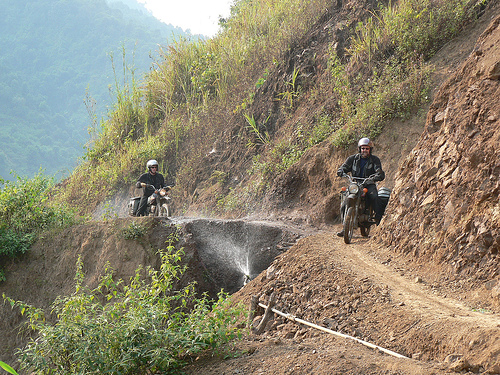Can you comment on the attire and preparation of the riders for this terrain? The riders are equipped with helmets, which is essential for safety on such treacherous paths. However, they do not appear to be wearing specialized off-road riding gear, which might suggest they are on a casual journey rather than a professional or intense off-roading experience. Their attire seems functional and suited for a motorbike trip through rough terrain, though additional protective gear would provide better safety. 